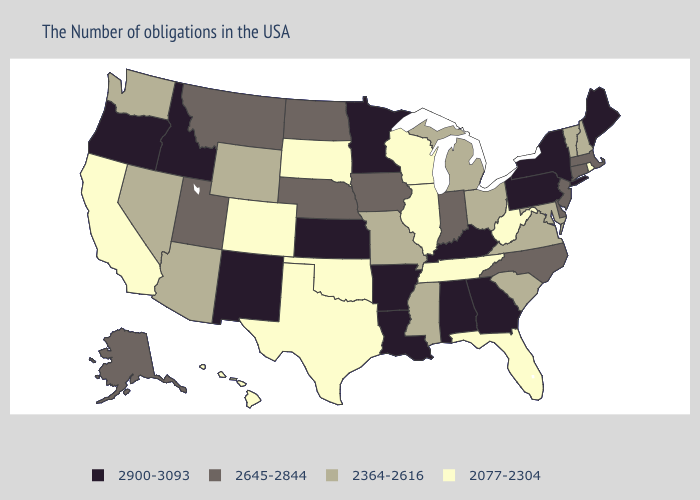Does North Dakota have a higher value than Nebraska?
Short answer required. No. Name the states that have a value in the range 2645-2844?
Answer briefly. Massachusetts, Connecticut, New Jersey, Delaware, North Carolina, Indiana, Iowa, Nebraska, North Dakota, Utah, Montana, Alaska. Does Georgia have the same value as Iowa?
Quick response, please. No. Name the states that have a value in the range 2364-2616?
Write a very short answer. New Hampshire, Vermont, Maryland, Virginia, South Carolina, Ohio, Michigan, Mississippi, Missouri, Wyoming, Arizona, Nevada, Washington. What is the value of Vermont?
Short answer required. 2364-2616. Does Idaho have the highest value in the West?
Quick response, please. Yes. Name the states that have a value in the range 2900-3093?
Quick response, please. Maine, New York, Pennsylvania, Georgia, Kentucky, Alabama, Louisiana, Arkansas, Minnesota, Kansas, New Mexico, Idaho, Oregon. What is the value of Arizona?
Keep it brief. 2364-2616. Name the states that have a value in the range 2645-2844?
Short answer required. Massachusetts, Connecticut, New Jersey, Delaware, North Carolina, Indiana, Iowa, Nebraska, North Dakota, Utah, Montana, Alaska. Which states have the lowest value in the USA?
Quick response, please. Rhode Island, West Virginia, Florida, Tennessee, Wisconsin, Illinois, Oklahoma, Texas, South Dakota, Colorado, California, Hawaii. Does Iowa have the highest value in the USA?
Keep it brief. No. Which states have the lowest value in the MidWest?
Short answer required. Wisconsin, Illinois, South Dakota. What is the highest value in the South ?
Give a very brief answer. 2900-3093. What is the lowest value in the Northeast?
Give a very brief answer. 2077-2304. What is the lowest value in the USA?
Be succinct. 2077-2304. 